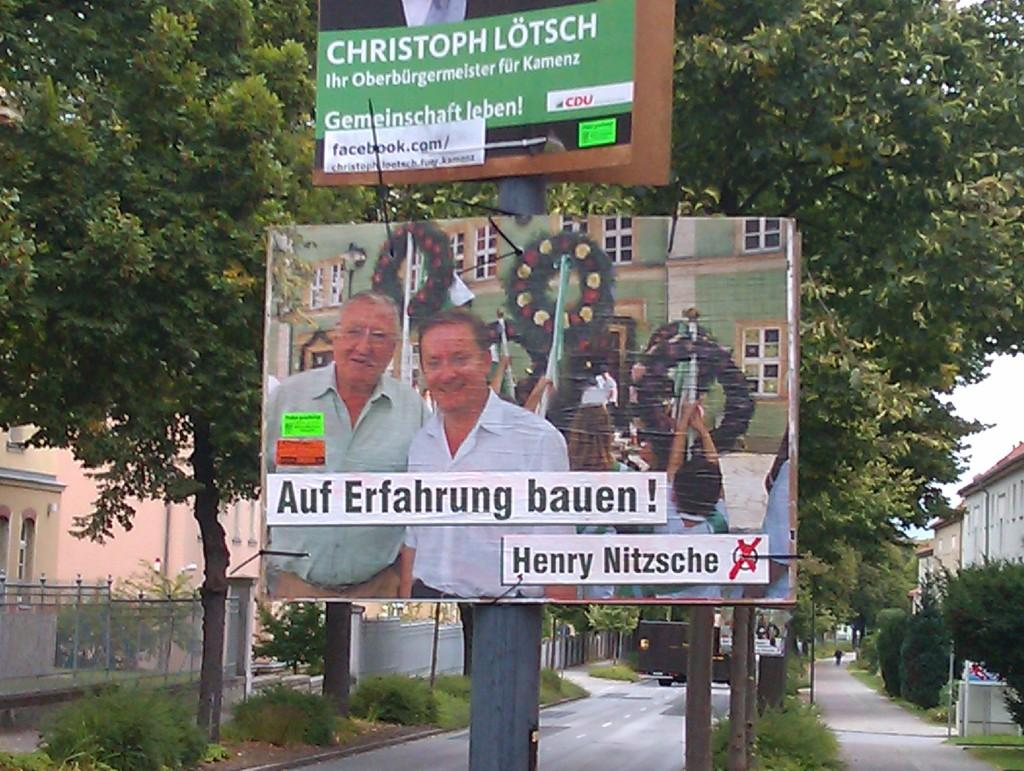<image>
Render a clear and concise summary of the photo. The election poster with the two men is for Henry Nitzsche. 